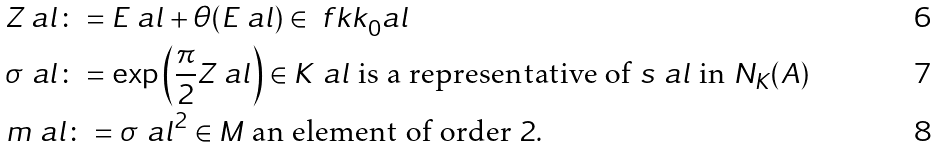Convert formula to latex. <formula><loc_0><loc_0><loc_500><loc_500>& Z _ { \ } a l \colon = E _ { \ } a l + \theta ( E _ { \ } a l ) \in \ f k k _ { 0 } ^ { \ } a l \\ & \sigma _ { \ } a l \colon = \exp \left ( \frac { \pi } { 2 } Z _ { \ } a l \right ) \in K ^ { \ } a l \text { is a  representative of } s _ { \ } a l \text { in } N _ { K } ( A ) \\ & m _ { \ } a l \colon = \sigma _ { \ } a l ^ { 2 } \in M \text { an element of order } 2 .</formula> 